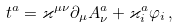Convert formula to latex. <formula><loc_0><loc_0><loc_500><loc_500>t ^ { a } = \varkappa ^ { \mu \nu } \partial _ { \mu } A _ { \nu } ^ { a } + \varkappa _ { i } ^ { a } \varphi _ { i } \, ,</formula> 